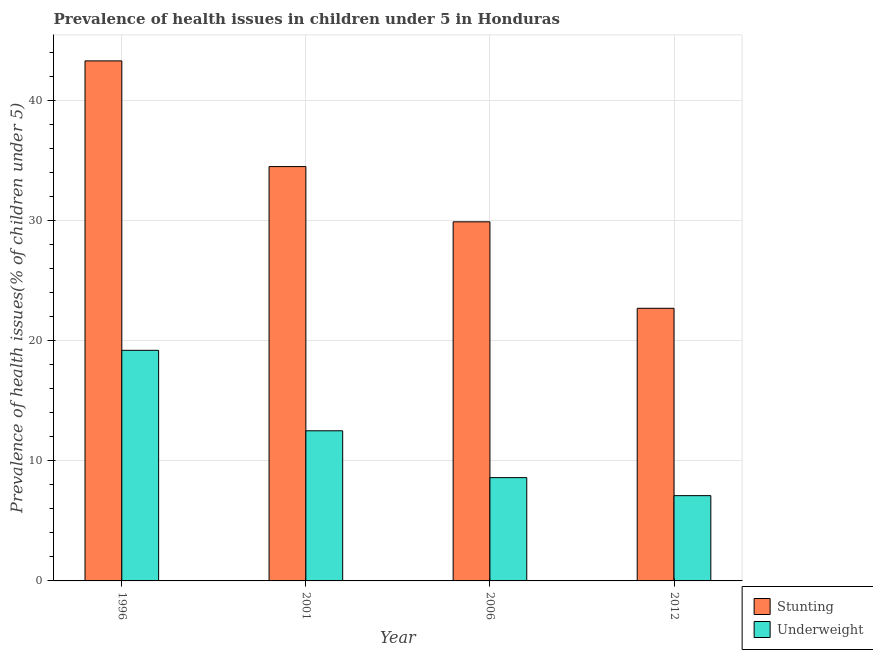How many different coloured bars are there?
Ensure brevity in your answer.  2. How many bars are there on the 4th tick from the left?
Offer a very short reply. 2. How many bars are there on the 4th tick from the right?
Your answer should be very brief. 2. What is the percentage of stunted children in 2012?
Make the answer very short. 22.7. Across all years, what is the maximum percentage of underweight children?
Provide a succinct answer. 19.2. Across all years, what is the minimum percentage of underweight children?
Your response must be concise. 7.1. What is the total percentage of stunted children in the graph?
Ensure brevity in your answer.  130.4. What is the difference between the percentage of stunted children in 2001 and that in 2006?
Keep it short and to the point. 4.6. What is the difference between the percentage of underweight children in 2001 and the percentage of stunted children in 2012?
Provide a short and direct response. 5.4. What is the average percentage of stunted children per year?
Provide a short and direct response. 32.6. In the year 2012, what is the difference between the percentage of stunted children and percentage of underweight children?
Offer a very short reply. 0. What is the ratio of the percentage of stunted children in 1996 to that in 2012?
Your response must be concise. 1.91. Is the percentage of stunted children in 1996 less than that in 2006?
Offer a terse response. No. Is the difference between the percentage of underweight children in 2001 and 2006 greater than the difference between the percentage of stunted children in 2001 and 2006?
Your answer should be very brief. No. What is the difference between the highest and the second highest percentage of stunted children?
Offer a terse response. 8.8. What is the difference between the highest and the lowest percentage of underweight children?
Your answer should be very brief. 12.1. Is the sum of the percentage of stunted children in 2001 and 2012 greater than the maximum percentage of underweight children across all years?
Your answer should be very brief. Yes. What does the 1st bar from the left in 2006 represents?
Provide a short and direct response. Stunting. What does the 2nd bar from the right in 2012 represents?
Provide a short and direct response. Stunting. Are all the bars in the graph horizontal?
Offer a terse response. No. Does the graph contain grids?
Provide a succinct answer. Yes. What is the title of the graph?
Make the answer very short. Prevalence of health issues in children under 5 in Honduras. What is the label or title of the Y-axis?
Provide a short and direct response. Prevalence of health issues(% of children under 5). What is the Prevalence of health issues(% of children under 5) in Stunting in 1996?
Your response must be concise. 43.3. What is the Prevalence of health issues(% of children under 5) of Underweight in 1996?
Ensure brevity in your answer.  19.2. What is the Prevalence of health issues(% of children under 5) of Stunting in 2001?
Make the answer very short. 34.5. What is the Prevalence of health issues(% of children under 5) of Stunting in 2006?
Provide a short and direct response. 29.9. What is the Prevalence of health issues(% of children under 5) of Underweight in 2006?
Your response must be concise. 8.6. What is the Prevalence of health issues(% of children under 5) in Stunting in 2012?
Your answer should be very brief. 22.7. What is the Prevalence of health issues(% of children under 5) in Underweight in 2012?
Make the answer very short. 7.1. Across all years, what is the maximum Prevalence of health issues(% of children under 5) in Stunting?
Your answer should be compact. 43.3. Across all years, what is the maximum Prevalence of health issues(% of children under 5) of Underweight?
Your response must be concise. 19.2. Across all years, what is the minimum Prevalence of health issues(% of children under 5) of Stunting?
Give a very brief answer. 22.7. Across all years, what is the minimum Prevalence of health issues(% of children under 5) of Underweight?
Keep it short and to the point. 7.1. What is the total Prevalence of health issues(% of children under 5) in Stunting in the graph?
Provide a short and direct response. 130.4. What is the total Prevalence of health issues(% of children under 5) in Underweight in the graph?
Provide a short and direct response. 47.4. What is the difference between the Prevalence of health issues(% of children under 5) of Stunting in 1996 and that in 2001?
Offer a very short reply. 8.8. What is the difference between the Prevalence of health issues(% of children under 5) of Stunting in 1996 and that in 2006?
Your answer should be compact. 13.4. What is the difference between the Prevalence of health issues(% of children under 5) in Stunting in 1996 and that in 2012?
Ensure brevity in your answer.  20.6. What is the difference between the Prevalence of health issues(% of children under 5) of Underweight in 1996 and that in 2012?
Keep it short and to the point. 12.1. What is the difference between the Prevalence of health issues(% of children under 5) in Stunting in 2001 and that in 2012?
Provide a short and direct response. 11.8. What is the difference between the Prevalence of health issues(% of children under 5) of Stunting in 1996 and the Prevalence of health issues(% of children under 5) of Underweight in 2001?
Your response must be concise. 30.8. What is the difference between the Prevalence of health issues(% of children under 5) of Stunting in 1996 and the Prevalence of health issues(% of children under 5) of Underweight in 2006?
Offer a very short reply. 34.7. What is the difference between the Prevalence of health issues(% of children under 5) of Stunting in 1996 and the Prevalence of health issues(% of children under 5) of Underweight in 2012?
Your response must be concise. 36.2. What is the difference between the Prevalence of health issues(% of children under 5) of Stunting in 2001 and the Prevalence of health issues(% of children under 5) of Underweight in 2006?
Ensure brevity in your answer.  25.9. What is the difference between the Prevalence of health issues(% of children under 5) of Stunting in 2001 and the Prevalence of health issues(% of children under 5) of Underweight in 2012?
Ensure brevity in your answer.  27.4. What is the difference between the Prevalence of health issues(% of children under 5) of Stunting in 2006 and the Prevalence of health issues(% of children under 5) of Underweight in 2012?
Your answer should be compact. 22.8. What is the average Prevalence of health issues(% of children under 5) of Stunting per year?
Provide a short and direct response. 32.6. What is the average Prevalence of health issues(% of children under 5) in Underweight per year?
Provide a succinct answer. 11.85. In the year 1996, what is the difference between the Prevalence of health issues(% of children under 5) in Stunting and Prevalence of health issues(% of children under 5) in Underweight?
Make the answer very short. 24.1. In the year 2001, what is the difference between the Prevalence of health issues(% of children under 5) in Stunting and Prevalence of health issues(% of children under 5) in Underweight?
Make the answer very short. 22. In the year 2006, what is the difference between the Prevalence of health issues(% of children under 5) of Stunting and Prevalence of health issues(% of children under 5) of Underweight?
Provide a succinct answer. 21.3. In the year 2012, what is the difference between the Prevalence of health issues(% of children under 5) in Stunting and Prevalence of health issues(% of children under 5) in Underweight?
Offer a terse response. 15.6. What is the ratio of the Prevalence of health issues(% of children under 5) of Stunting in 1996 to that in 2001?
Offer a very short reply. 1.26. What is the ratio of the Prevalence of health issues(% of children under 5) of Underweight in 1996 to that in 2001?
Offer a very short reply. 1.54. What is the ratio of the Prevalence of health issues(% of children under 5) of Stunting in 1996 to that in 2006?
Provide a short and direct response. 1.45. What is the ratio of the Prevalence of health issues(% of children under 5) of Underweight in 1996 to that in 2006?
Provide a succinct answer. 2.23. What is the ratio of the Prevalence of health issues(% of children under 5) in Stunting in 1996 to that in 2012?
Offer a very short reply. 1.91. What is the ratio of the Prevalence of health issues(% of children under 5) of Underweight in 1996 to that in 2012?
Offer a terse response. 2.7. What is the ratio of the Prevalence of health issues(% of children under 5) in Stunting in 2001 to that in 2006?
Offer a very short reply. 1.15. What is the ratio of the Prevalence of health issues(% of children under 5) of Underweight in 2001 to that in 2006?
Ensure brevity in your answer.  1.45. What is the ratio of the Prevalence of health issues(% of children under 5) of Stunting in 2001 to that in 2012?
Offer a very short reply. 1.52. What is the ratio of the Prevalence of health issues(% of children under 5) of Underweight in 2001 to that in 2012?
Offer a terse response. 1.76. What is the ratio of the Prevalence of health issues(% of children under 5) of Stunting in 2006 to that in 2012?
Your answer should be compact. 1.32. What is the ratio of the Prevalence of health issues(% of children under 5) of Underweight in 2006 to that in 2012?
Offer a terse response. 1.21. What is the difference between the highest and the second highest Prevalence of health issues(% of children under 5) of Stunting?
Your response must be concise. 8.8. What is the difference between the highest and the lowest Prevalence of health issues(% of children under 5) of Stunting?
Make the answer very short. 20.6. 